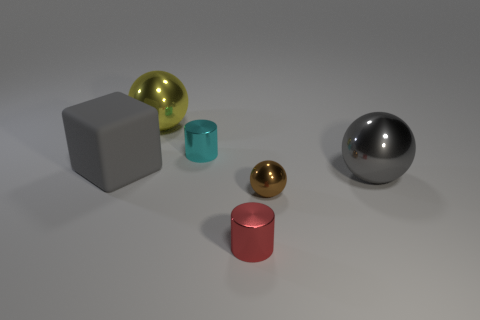There is a gray thing to the left of the metallic sphere that is to the left of the red thing left of the tiny brown metal ball; how big is it?
Provide a succinct answer. Large. How many other objects are the same shape as the tiny cyan thing?
Ensure brevity in your answer.  1. There is a large metal object behind the gray metal sphere; is it the same shape as the large object that is right of the tiny cyan object?
Your answer should be very brief. Yes. How many balls are big yellow metal things or large gray metal things?
Your answer should be compact. 2. There is a large gray thing on the left side of the metallic cylinder in front of the big gray object left of the big gray ball; what is its material?
Provide a short and direct response. Rubber. What is the size of the sphere that is the same color as the big matte thing?
Provide a short and direct response. Large. Is the number of tiny brown metallic spheres that are behind the red metal object greater than the number of red rubber balls?
Provide a short and direct response. Yes. Is there a shiny sphere that has the same color as the rubber cube?
Your answer should be compact. Yes. What is the color of the other metal cylinder that is the same size as the red metal cylinder?
Your answer should be very brief. Cyan. There is a small cylinder behind the brown metallic thing; what number of large metallic objects are right of it?
Your answer should be very brief. 1. 